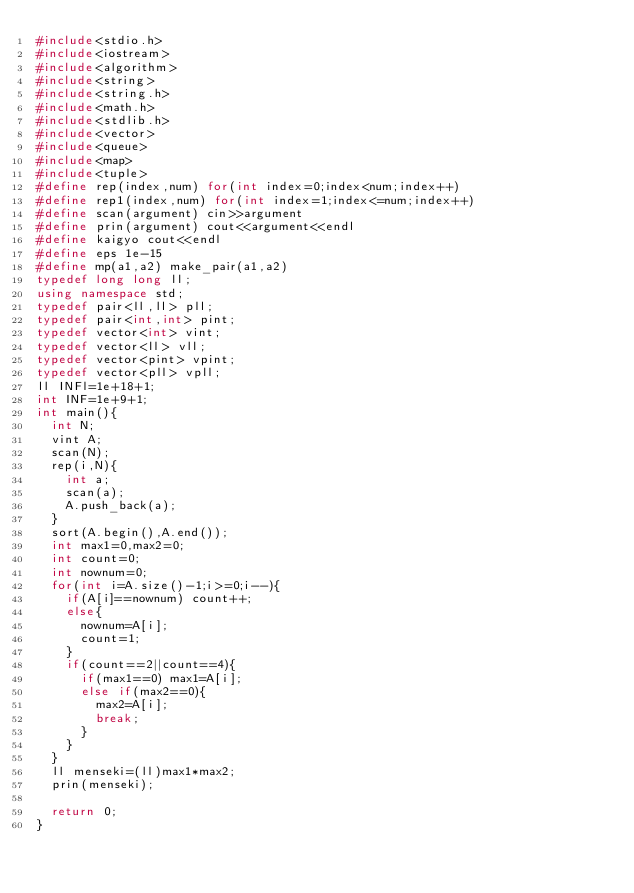Convert code to text. <code><loc_0><loc_0><loc_500><loc_500><_C++_>#include<stdio.h>
#include<iostream>
#include<algorithm>
#include<string>
#include<string.h>
#include<math.h>
#include<stdlib.h>
#include<vector>
#include<queue>
#include<map>
#include<tuple>
#define rep(index,num) for(int index=0;index<num;index++)
#define rep1(index,num) for(int index=1;index<=num;index++)
#define scan(argument) cin>>argument
#define prin(argument) cout<<argument<<endl
#define kaigyo cout<<endl
#define eps 1e-15
#define mp(a1,a2) make_pair(a1,a2)
typedef long long ll;
using namespace std;
typedef pair<ll,ll> pll;
typedef pair<int,int> pint;
typedef vector<int> vint;
typedef vector<ll> vll;
typedef vector<pint> vpint;
typedef vector<pll> vpll;
ll INFl=1e+18+1;
int INF=1e+9+1;
int main(){
	int N;
	vint A;
	scan(N);
	rep(i,N){
		int a;
		scan(a);
		A.push_back(a);
	}
	sort(A.begin(),A.end());
	int max1=0,max2=0;
	int count=0;
	int nownum=0;
	for(int i=A.size()-1;i>=0;i--){
		if(A[i]==nownum) count++;
		else{
			nownum=A[i];
			count=1;
		}
		if(count==2||count==4){
			if(max1==0) max1=A[i];
			else if(max2==0){
				max2=A[i];
				break;
			}
		}
	}
	ll menseki=(ll)max1*max2;
	prin(menseki);

	return 0;
}
</code> 